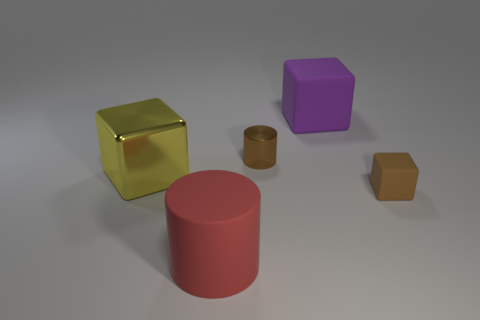Add 3 shiny cylinders. How many objects exist? 8 Subtract all cylinders. How many objects are left? 3 Subtract all brown objects. Subtract all brown rubber things. How many objects are left? 2 Add 2 small things. How many small things are left? 4 Add 5 small brown metallic objects. How many small brown metallic objects exist? 6 Subtract 1 red cylinders. How many objects are left? 4 